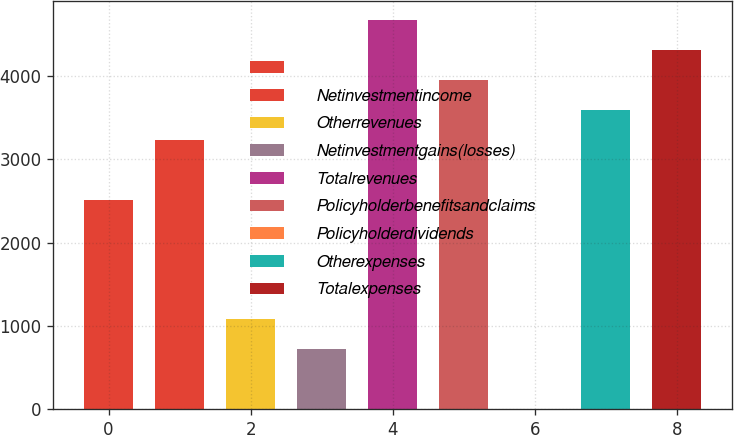Convert chart to OTSL. <chart><loc_0><loc_0><loc_500><loc_500><bar_chart><ecel><fcel>Netinvestmentincome<fcel>Otherrevenues<fcel>Netinvestmentgains(losses)<fcel>Totalrevenues<fcel>Policyholderbenefitsandclaims<fcel>Policyholderdividends<fcel>Otherexpenses<fcel>Totalexpenses<nl><fcel>2515.2<fcel>3232.4<fcel>1080.8<fcel>722.2<fcel>4666.8<fcel>3949.6<fcel>5<fcel>3591<fcel>4308.2<nl></chart> 